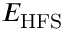<formula> <loc_0><loc_0><loc_500><loc_500>E _ { H F S }</formula> 